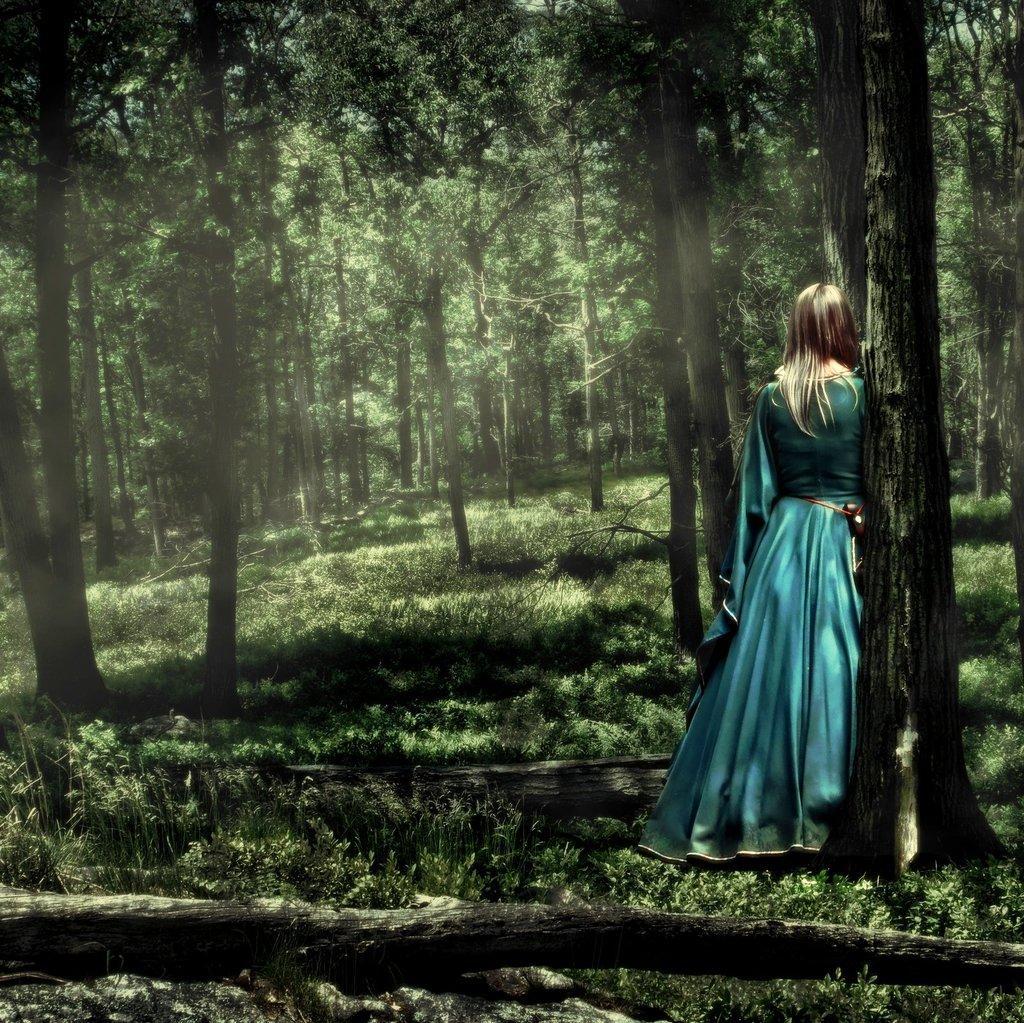Please provide a concise description of this image. This is a graphic image, in the image there are some trees, a trunk of tree at the bottom there is a person standing in front of tree on the right side. 